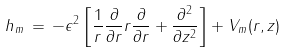<formula> <loc_0><loc_0><loc_500><loc_500>h _ { m } \, = \, - \epsilon ^ { 2 } \left [ \frac { 1 } { r } \frac { \partial } { \partial r } r \frac { \partial } { \partial r } + \frac { \partial ^ { 2 } } { \partial z ^ { 2 } } \right ] + V _ { m } ( r , z )</formula> 